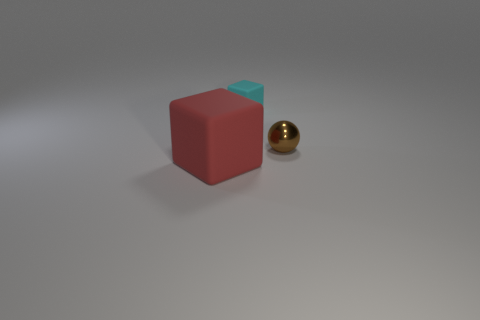Add 3 large purple balls. How many objects exist? 6 Subtract all red blocks. How many blocks are left? 1 Subtract all cyan spheres. Subtract all yellow cylinders. How many spheres are left? 1 Subtract all red spheres. How many gray cubes are left? 0 Subtract all big cyan rubber cylinders. Subtract all matte objects. How many objects are left? 1 Add 1 tiny rubber cubes. How many tiny rubber cubes are left? 2 Add 1 tiny cyan cubes. How many tiny cyan cubes exist? 2 Subtract 1 red blocks. How many objects are left? 2 Subtract all spheres. How many objects are left? 2 Subtract 1 cubes. How many cubes are left? 1 